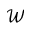Convert formula to latex. <formula><loc_0><loc_0><loc_500><loc_500>\mathcal { W }</formula> 